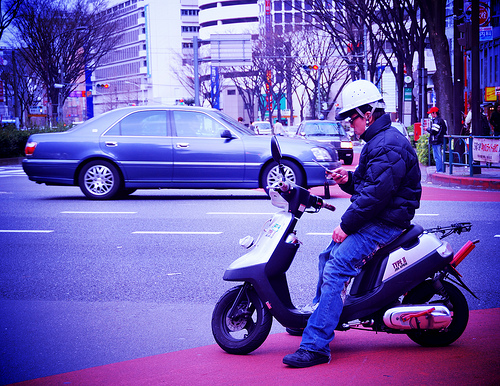Is there anything that indicates the location or country where this photo was taken? There are some textual elements in the background, but they are not clearly legible, making it difficult to determine the specific country or location from this image alone. 